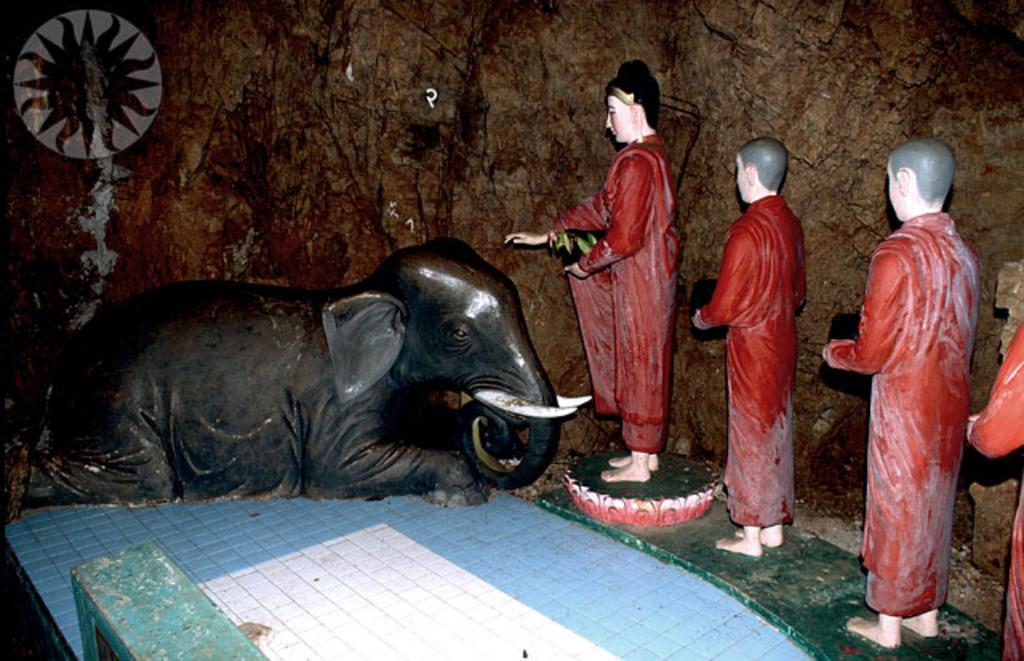Please provide a concise description of this image. In this picture we can see an elephant statue, and few other statues. 